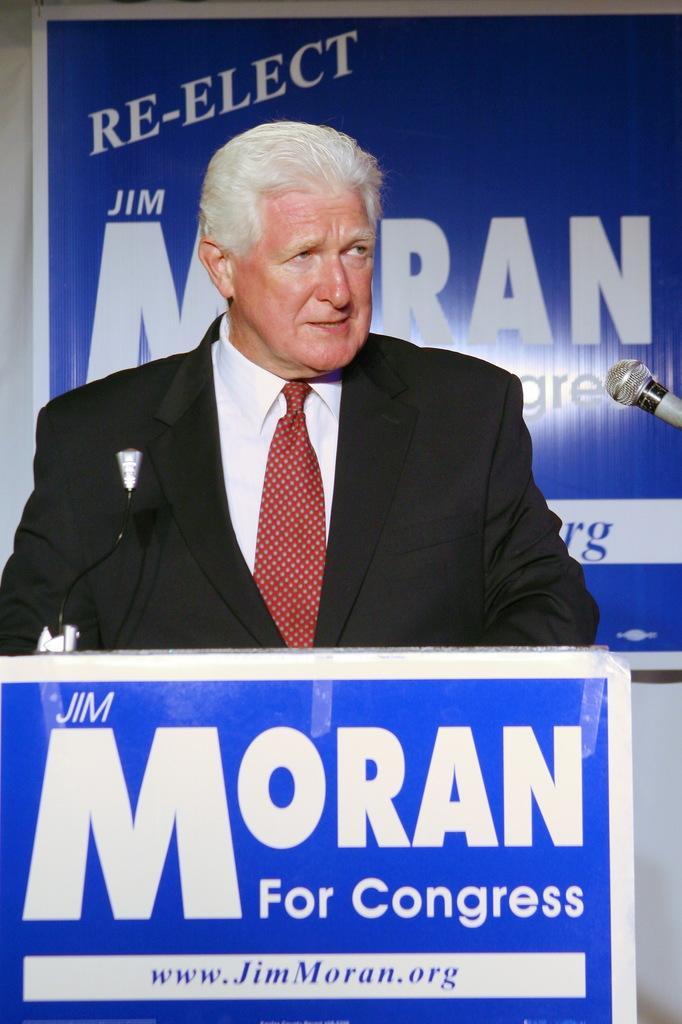Please provide a concise description of this image. In the center of this picture there is a person wearing suit and standing, in front of him there is a white color object seems to be a podium and we can see a blue color board on which the text is printed. On the right corner there is a microphone. In the background there is a blue color banner on which we can see the text and we can see the wall. 